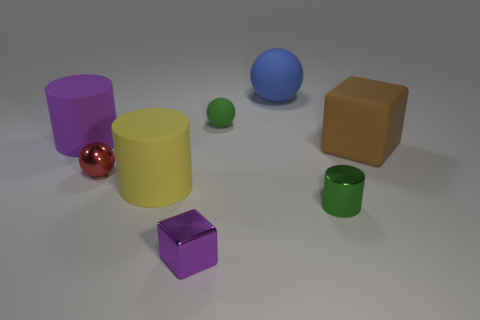What number of other things are the same size as the purple cylinder?
Offer a terse response. 3. Does the block on the right side of the small green cylinder have the same material as the red ball?
Provide a short and direct response. No. How many other things are there of the same color as the tiny metallic cylinder?
Make the answer very short. 1. How many other things are there of the same shape as the big brown object?
Make the answer very short. 1. Does the small metal thing that is in front of the tiny cylinder have the same shape as the metal object that is to the left of the yellow cylinder?
Provide a succinct answer. No. Is the number of matte spheres that are on the right side of the blue thing the same as the number of cylinders on the right side of the small red metal thing?
Make the answer very short. No. What is the shape of the purple object that is in front of the purple thing that is behind the tiny purple object in front of the red sphere?
Offer a terse response. Cube. Is the material of the small object that is to the left of the purple cube the same as the big cylinder that is behind the yellow thing?
Give a very brief answer. No. There is a purple object behind the tiny purple block; what is its shape?
Ensure brevity in your answer.  Cylinder. Is the number of spheres less than the number of purple blocks?
Provide a short and direct response. No. 